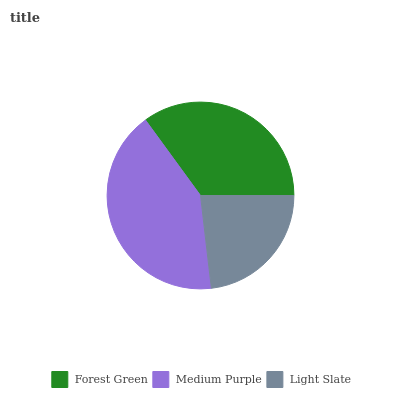Is Light Slate the minimum?
Answer yes or no. Yes. Is Medium Purple the maximum?
Answer yes or no. Yes. Is Medium Purple the minimum?
Answer yes or no. No. Is Light Slate the maximum?
Answer yes or no. No. Is Medium Purple greater than Light Slate?
Answer yes or no. Yes. Is Light Slate less than Medium Purple?
Answer yes or no. Yes. Is Light Slate greater than Medium Purple?
Answer yes or no. No. Is Medium Purple less than Light Slate?
Answer yes or no. No. Is Forest Green the high median?
Answer yes or no. Yes. Is Forest Green the low median?
Answer yes or no. Yes. Is Light Slate the high median?
Answer yes or no. No. Is Medium Purple the low median?
Answer yes or no. No. 